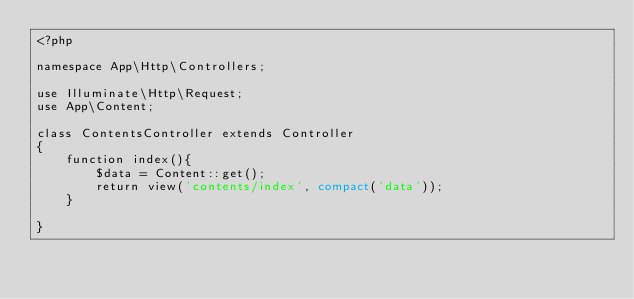<code> <loc_0><loc_0><loc_500><loc_500><_PHP_><?php

namespace App\Http\Controllers;

use Illuminate\Http\Request;
use App\Content;

class ContentsController extends Controller
{
    function index(){
        $data = Content::get();
        return view('contents/index', compact('data'));
    }

}
</code> 